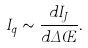<formula> <loc_0><loc_0><loc_500><loc_500>I _ { q } \sim \frac { d I _ { J } } { d \Delta \phi } .</formula> 